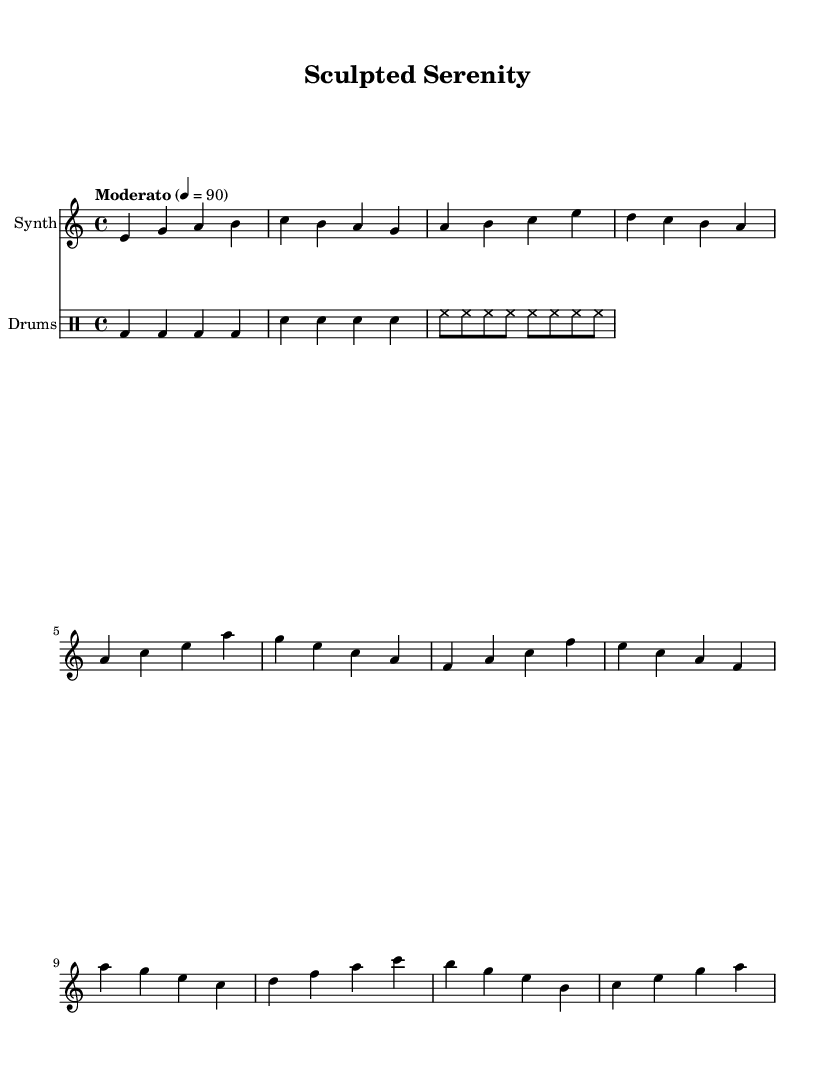What is the key signature of this music? The key signature is A minor, which has no sharps or flats.
Answer: A minor What is the time signature of the music? The time signature is 4/4, indicating four beats per measure.
Answer: 4/4 What is the tempo marking indicated in the score? The tempo marking is "Moderato" at a speed of 90 beats per minute, which suggests a moderate pace.
Answer: Moderato What is the highest note in the synthesizer part? The highest note in the synthesizer part is B, found in the chorus section.
Answer: B How many measures are in the synthesizer part before the chorus? The synthesizer part has eight measures before the chorus section starts. This includes the intro and the verse.
Answer: 8 What type of rhythms do the drums use? The drum part employs a combination of quarter notes for bass and snare, with eighth notes for hi-hat, which contributes to the typical electronic music feel.
Answer: Combination In which section does the melody first ascend to the highest pitch? The melody first ascends to the highest pitch in the chorus section, where the notes rise to B and C.
Answer: Chorus 